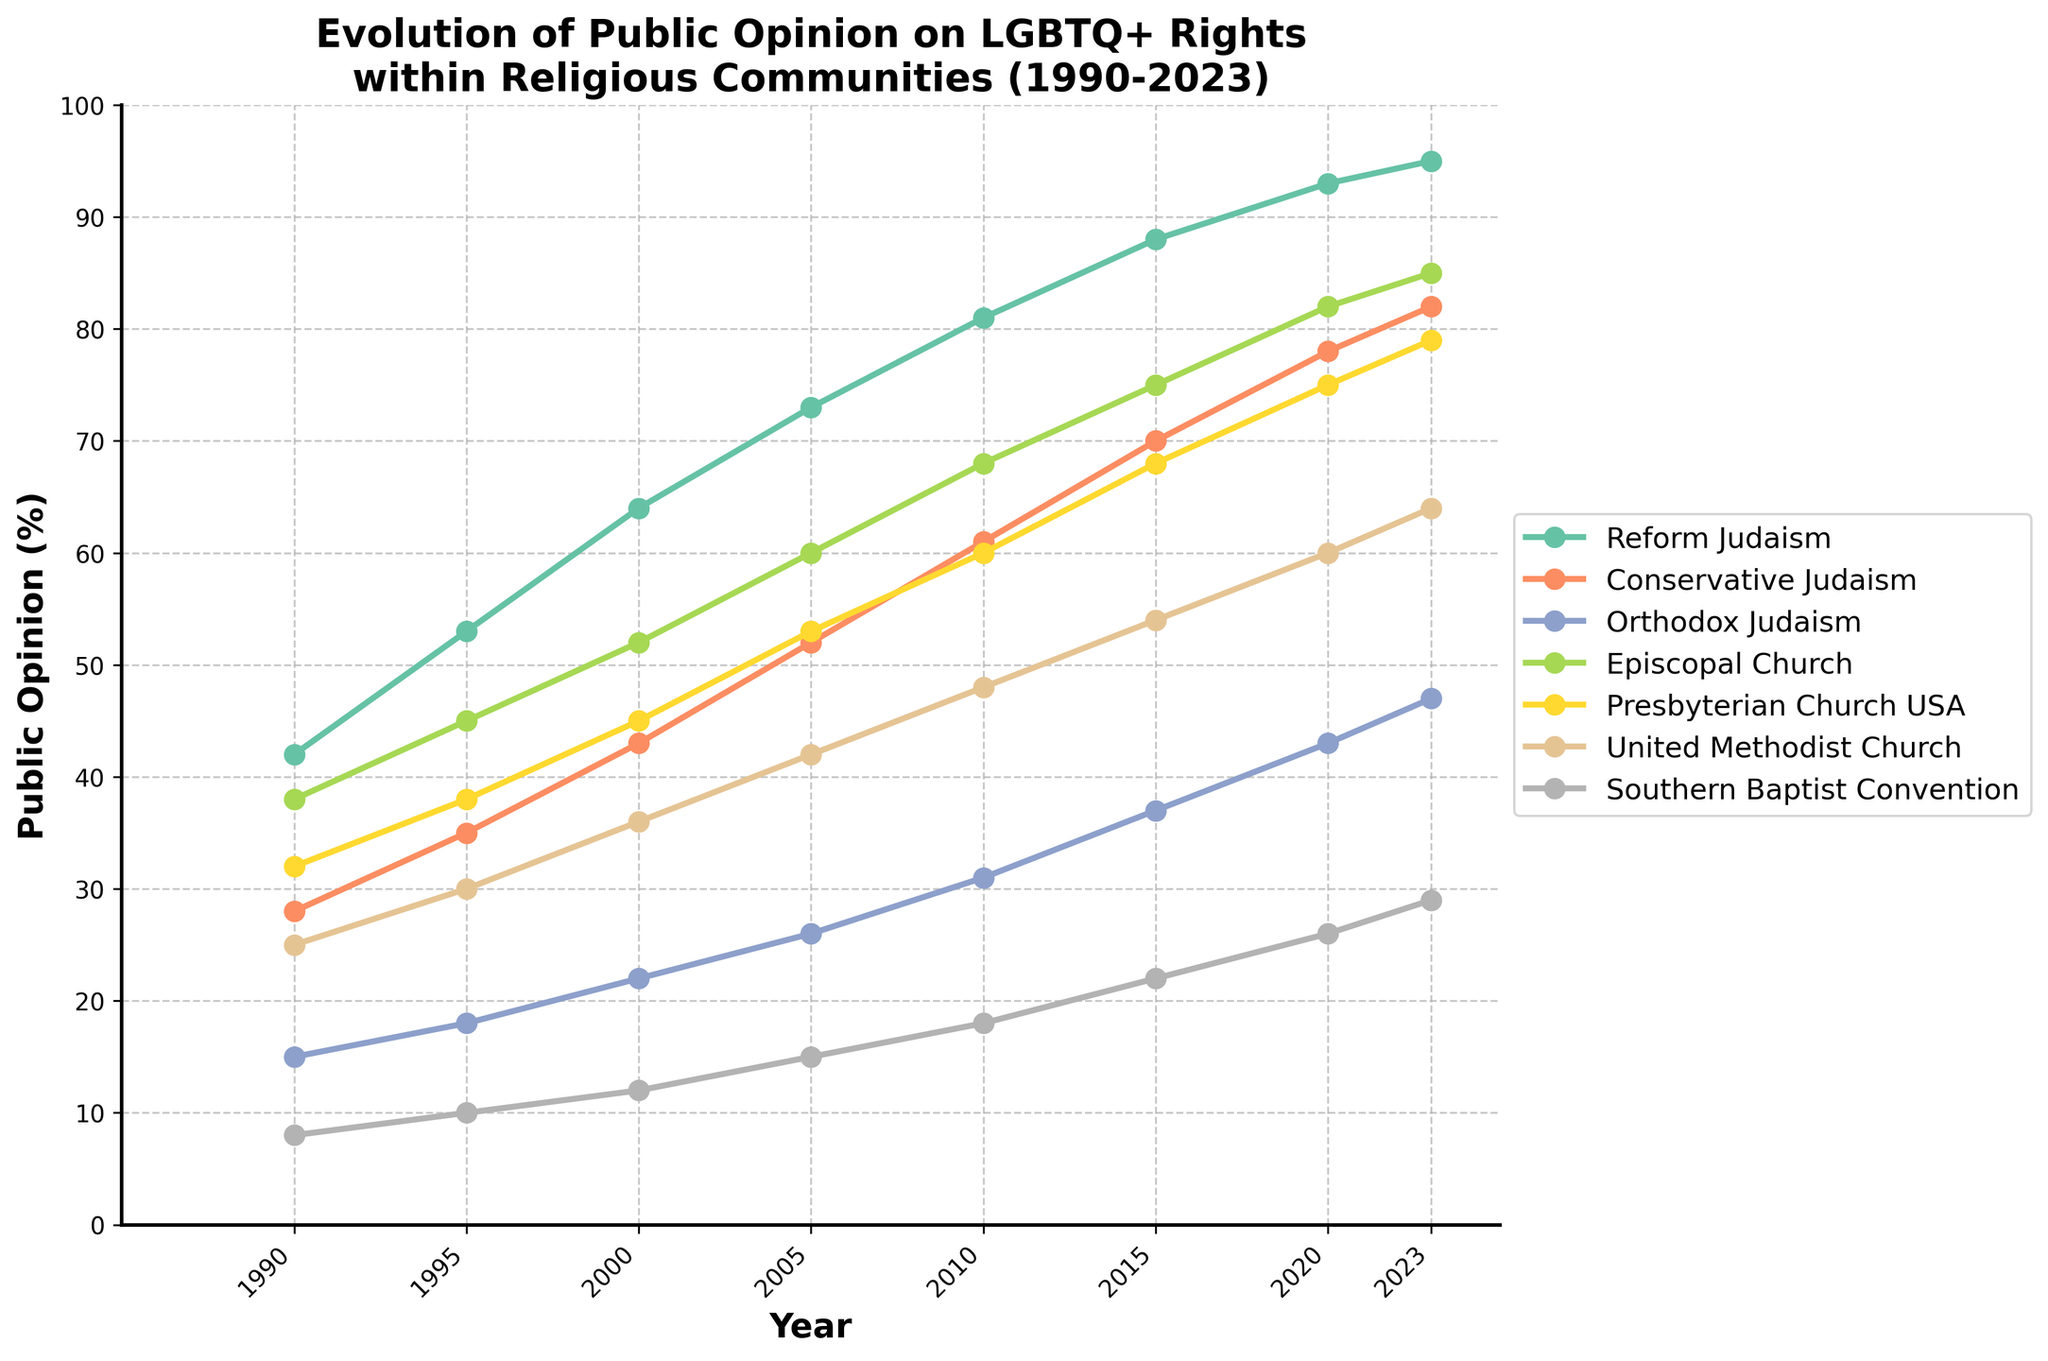What was the public opinion on LGBTQ+ rights within the Episcopal Church in 2000? Look for the data point corresponding to the Episcopal Church in the year 2000.
Answer: 52% Which denomination had the highest public support for LGBTQ+ rights in 2023? Identify the highest value among all denominations in 2023. Reform Judaism has the highest percentage.
Answer: Reform Judaism How much did public opinion on LGBTQ+ rights within Orthodox Judaism change from 1990 to 2023? Calculate the difference between the values for Orthodox Judaism in 2023 and 1990: 47 - 15 = 32.
Answer: 32% Which denomination exhibited the most significant increase in public opinion on LGBTQ+ rights between 1990 and 2023? Calculate the change for each denomination and compare them. Reform Judaism increased by 53% (95% - 42%).
Answer: Reform Judaism In 2010, did the United Methodist Church have higher public support for LGBTQ+ rights compared to the Southern Baptist Convention? Compare the values for the United Methodist Church (48%) and the Southern Baptist Convention (18%) in 2010.
Answer: Yes What year did the Presbyterian Church USA first surpass 60% in public support for LGBTQ+ rights? Look for the first year where the Presbyterian Church USA value exceeds 60%.
Answer: 2010 Compare the slopes of the lines representing Conservative Judaism and Southern Baptist Convention between 2005 and 2015. Which one is steeper? Calculate the slope for both: Conservative Judaism (70-52)/10 = 1.8, Southern Baptist Convention (22-15)/10 = 0.7. The slope for Conservative Judaism is steeper.
Answer: Conservative Judaism By how much did public opinion on LGBTQ+ rights in Reform Judaism increase between 1995 and 2005? Calculate the difference between the values for Reform Judaism in 1995 and 2005: 73 - 53 = 20.
Answer: 20% What is the average public opinion on LGBTQ+ rights in the Southern Baptist Convention across all years listed? Sum the values for Southern Baptist Convention and divide by the number of years: (8 + 10 + 12 + 15 + 18 + 22 + 26 + 29) / 8 = 17.5.
Answer: 17.5% Did any denomination have a consistent linear increase in public opinion on LGBTQ+ rights from 1990 to 2023? Examine the trend lines for each denomination to identify any with consistent linear growth. Reform Judaism shows a consistent linear increase.
Answer: Reform Judaism 